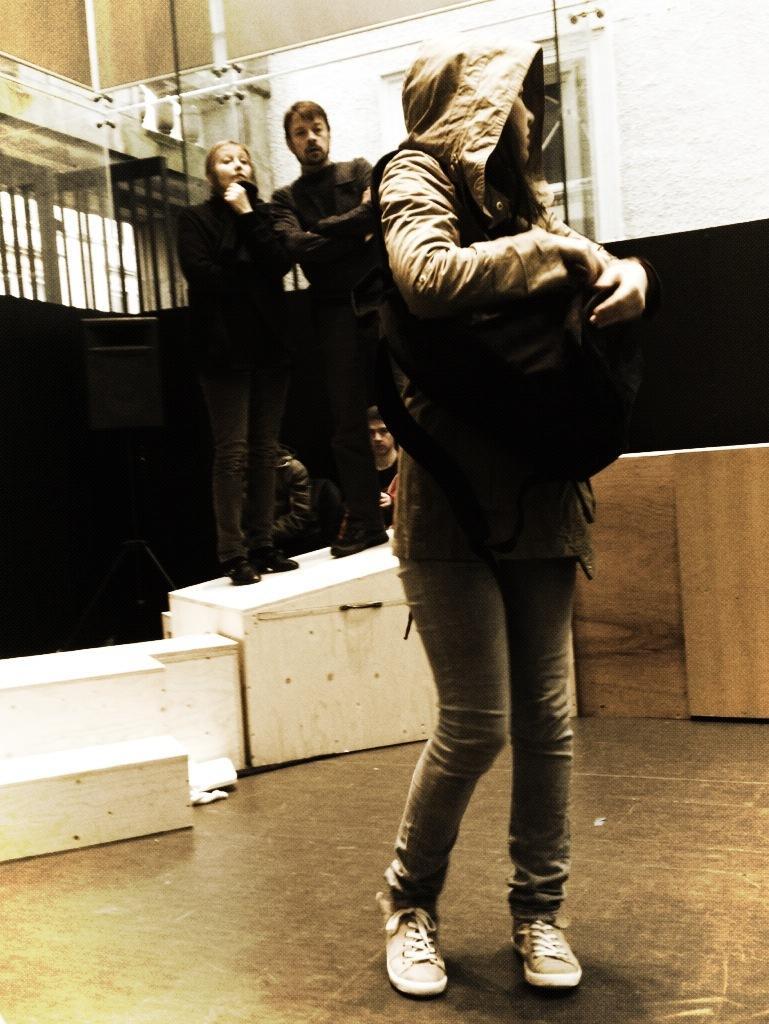Please provide a concise description of this image. In this image there is floor at the bottom. There is a person standing and she is holding a bag in the foreground. There is a wooden object on the left and right corner. There are wooden objects, there are people, there is colored object in the background. 